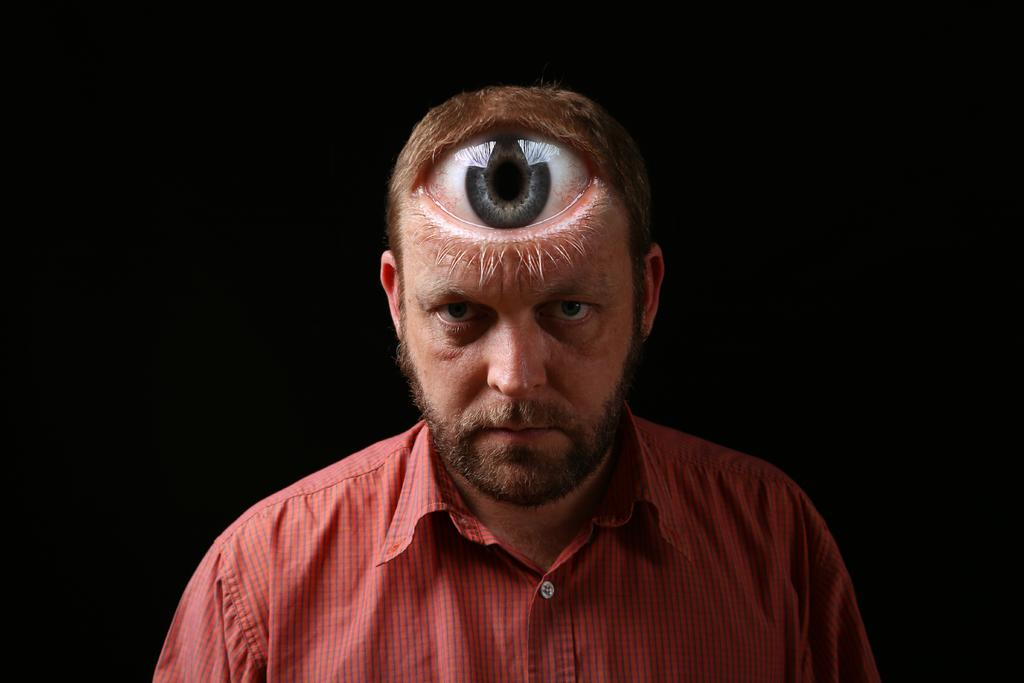What is present in the image? There is a person in the image. What is the person wearing? The person is wearing a red color shirt. What color is the background of the image? The background of the image is black. What type of body is visible in the image? There is no body visible in the image, only a person wearing a red color shirt. What is the value of the person's shirt in the image? The value of the person's shirt cannot be determined from the image, as it is a qualitative description. 